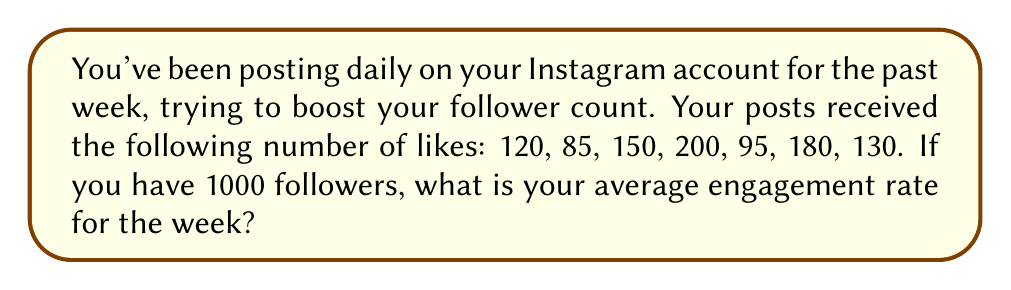Teach me how to tackle this problem. To calculate the average engagement rate, we need to follow these steps:

1. Calculate the total number of likes:
   $120 + 85 + 150 + 200 + 95 + 180 + 130 = 960$ likes

2. Calculate the average number of likes per post:
   $\text{Average likes} = \frac{\text{Total likes}}{\text{Number of posts}} = \frac{960}{7} \approx 137.14$ likes

3. Calculate the engagement rate for the week:
   $\text{Engagement rate} = \frac{\text{Average likes}}{\text{Number of followers}} \times 100\%$
   
   $\text{Engagement rate} = \frac{137.14}{1000} \times 100\% \approx 13.714\%$

Therefore, the average engagement rate for the week is approximately 13.714%.
Answer: $13.714\%$ 